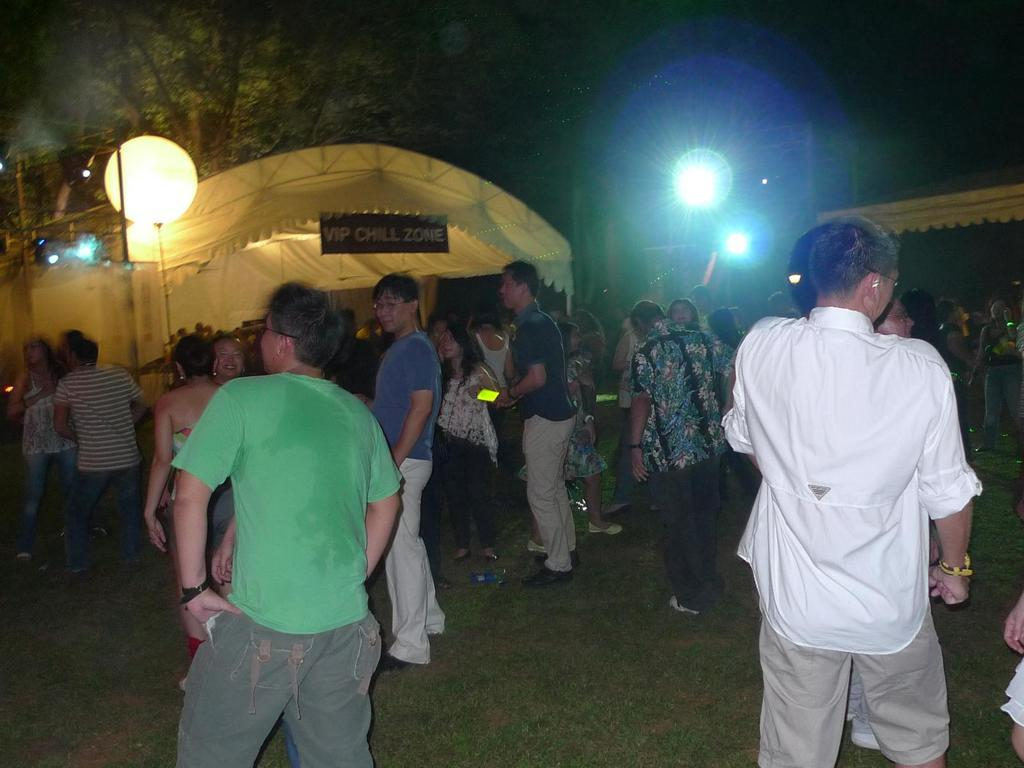What objects are visible in the image that emit light? There are lights in the image. Who or what is present in the image along with the lights? There are people in the image. What type of structures can be seen in the image? There are sheds in the image. What type of natural environment is visible in the image? There is grass and trees in the image. Can you tell me where the aunt is playing the drum in the image? There is no aunt or drum present in the image. What type of need is being fulfilled by the people in the image? There is no specific need being fulfilled by the people in the image; they are simply present in the image. 